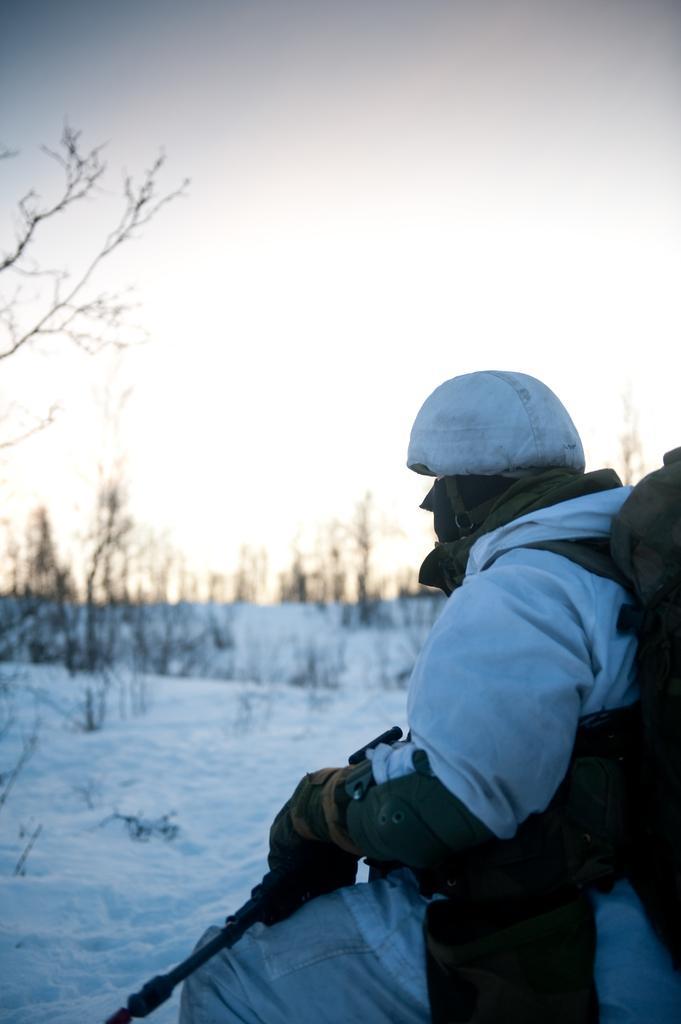Could you give a brief overview of what you see in this image? In this image I can see the person with the dress and holding the stick. I can see the snow and many trees. In the background I can see the sky. 